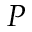<formula> <loc_0><loc_0><loc_500><loc_500>P</formula> 